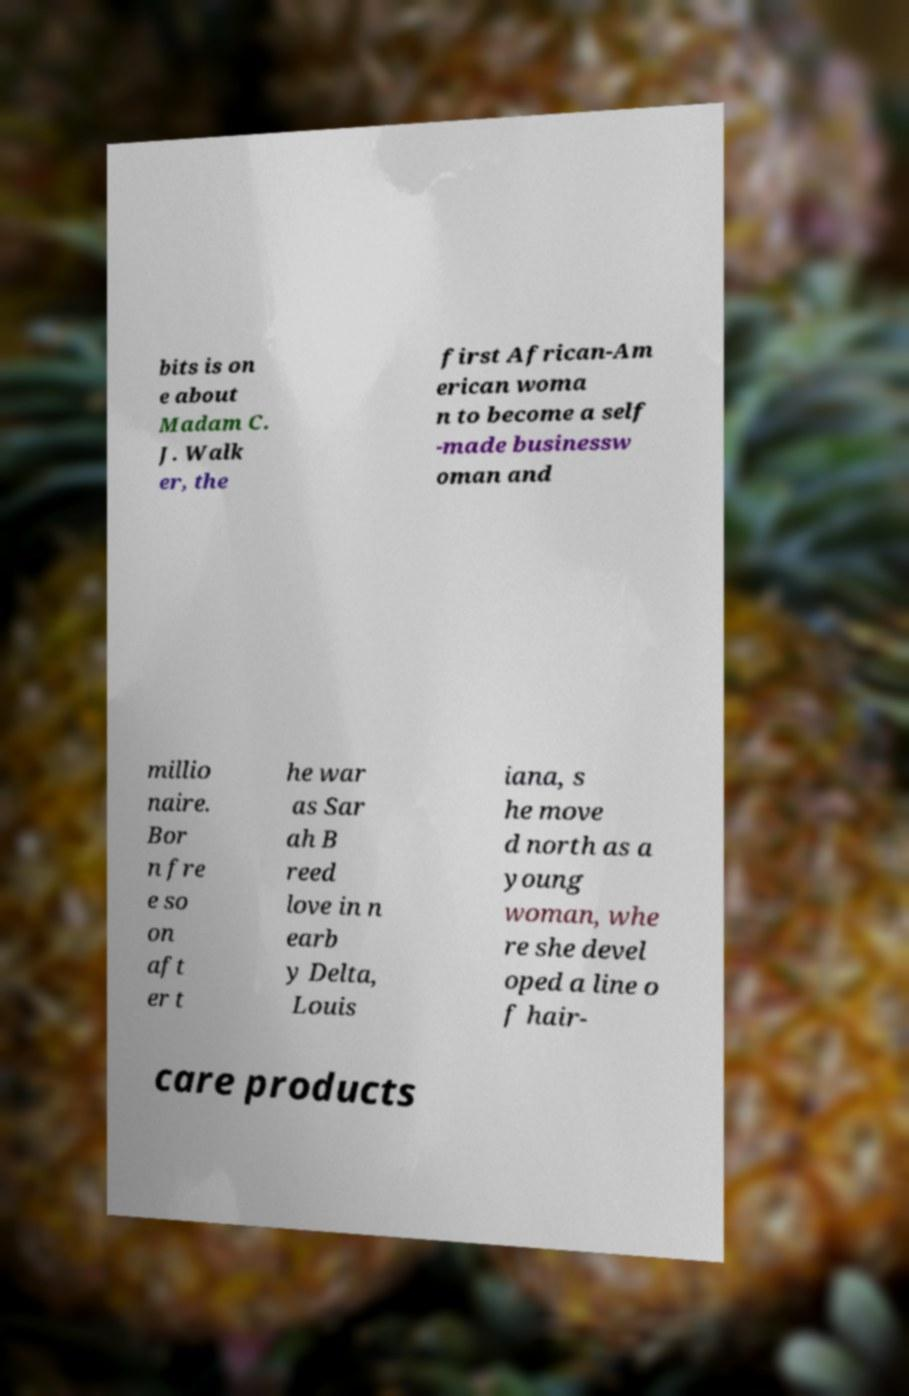Could you assist in decoding the text presented in this image and type it out clearly? bits is on e about Madam C. J. Walk er, the first African-Am erican woma n to become a self -made businessw oman and millio naire. Bor n fre e so on aft er t he war as Sar ah B reed love in n earb y Delta, Louis iana, s he move d north as a young woman, whe re she devel oped a line o f hair- care products 